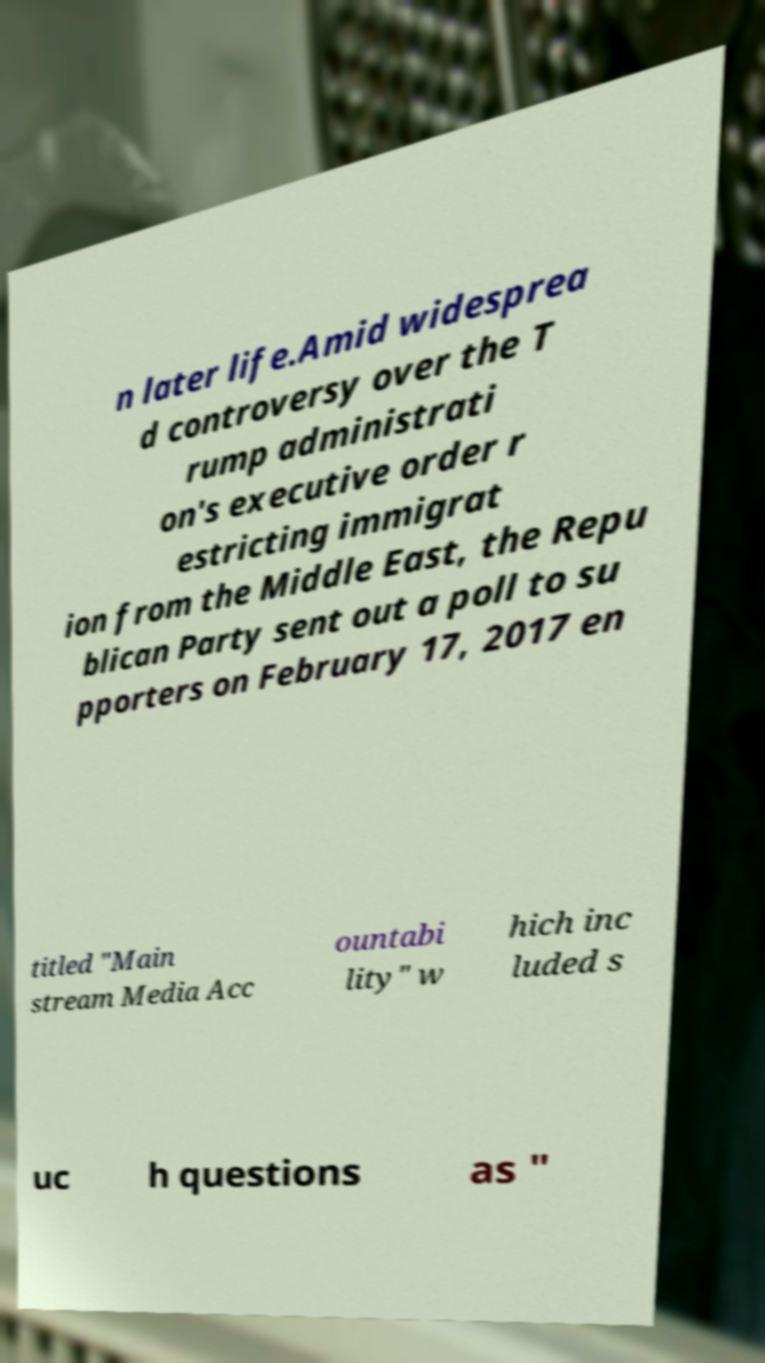Could you assist in decoding the text presented in this image and type it out clearly? n later life.Amid widesprea d controversy over the T rump administrati on's executive order r estricting immigrat ion from the Middle East, the Repu blican Party sent out a poll to su pporters on February 17, 2017 en titled "Main stream Media Acc ountabi lity" w hich inc luded s uc h questions as " 